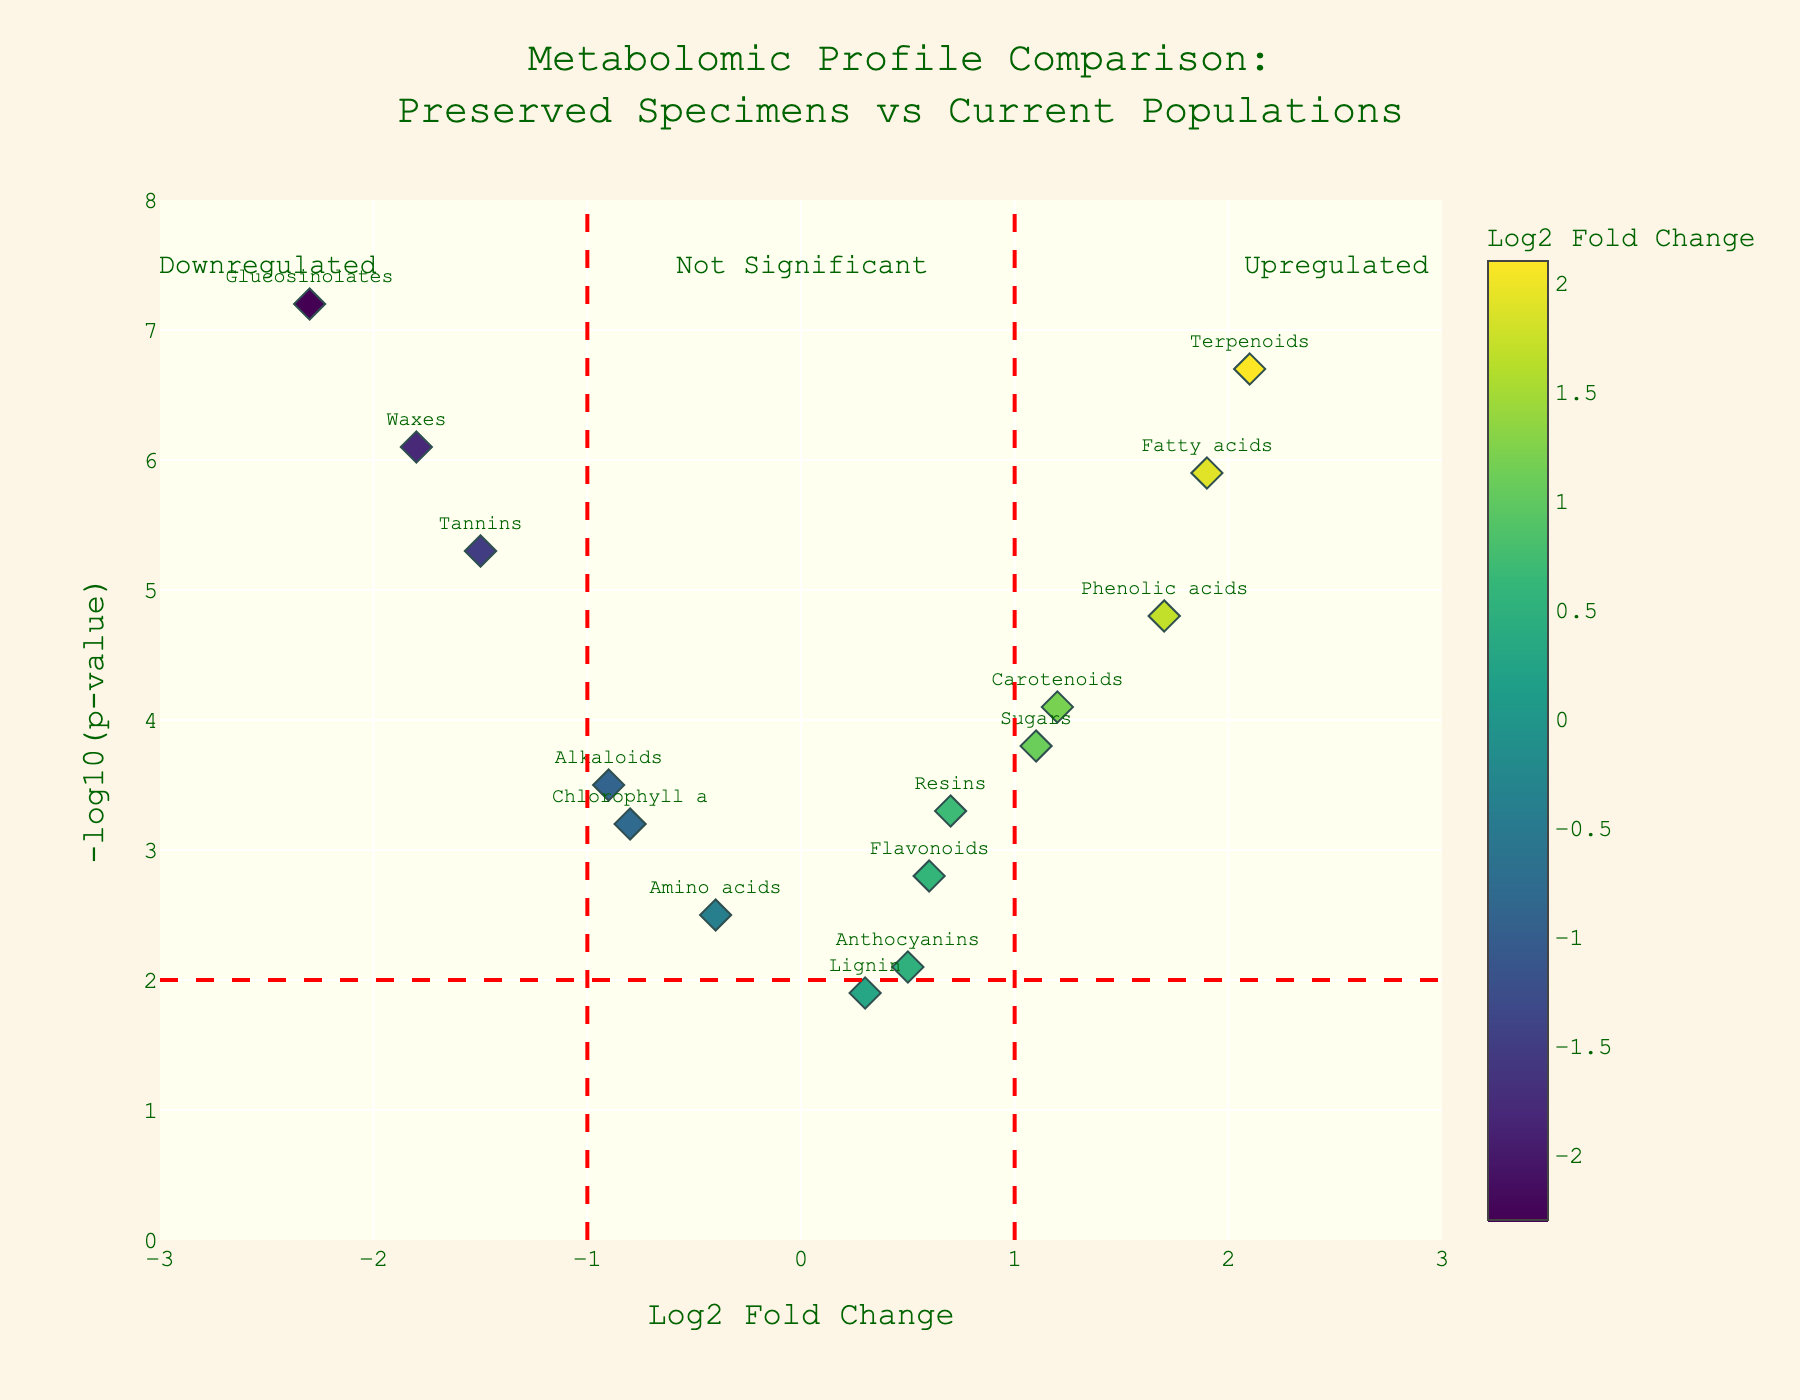What is the title of the figure? The title of a figure is usually found at the top and provides an overview of what the data visualization represents. In this case, it states the purpose of the plot, comparing metabolomic profiles between preserved specimens and current populations.
Answer: Metabolomic Profile Comparison: Preserved Specimens vs Current Populations What is represented on the x-axis and y-axis? The x-axis and y-axis labels describe the data dimensions. The x-axis represents the 'Log2 Fold Change,' indicating the magnitude of change between two conditions. The y-axis represents the '-log10(p-value),' indicating the statistical significance of the change.
Answer: x-axis: Log2 Fold Change, y-axis: -log10(p-value) Which compound has the highest -log10(p-value)? To identify this, look at the y-axis values. The highest plot point on the y-axis denotes the most statistically significant difference. The compound associated with this point is "Glucosinolates."
Answer: Glucosinolates How many compounds have a Log2 Fold Change greater than 1? Count the data points to the right of the vertical line at Log2 Fold Change = 1. The relevant compounds are: Carotenoids, Terpenoids, Fatty acids, Phenolic acids, and Sugars.
Answer: 5 Which compound is the most downregulated? Look for the compound with the lowest Log2 Fold Change value. In this case, "Glucosinolates" has the lowest value at -2.3.
Answer: Glucosinolates Compare the statistical significance between Terpenoids and Tannins. To compare, look at their -log10(p-value) values on the y-axis. Terpenoids have a value of 6.7 while Tannins have a value of 5.3. Thus, Terpenoids are more statistically significant.
Answer: Terpenoids Which compounds are neither upregulated nor downregulated significantly? These compounds are close to Log2 Fold Change of 0 and have a -log10(p-value) less than 2. The relevant compounds are Lignin and Amino acids.
Answer: Lignin, Amino acids How many compounds are highly statistically significant with a -log10(p-value) greater than 6? Count the data points above the horizontal line at -log10(p-value) = 6. The relevant compounds are Terpenoids, Glucosinolates, and Waxes.
Answer: 3 Are there more upregulated or downregulated compounds when Log2 Fold Change thresholds are set at ±1? Count the points to the right of +1 and to the left of -1. There are 5 compounds upregulated (Log2 Fold > 1) and 4 compounds downregulated (Log2 Fold < -1).
Answer: Upregulated Which compound has a Log2 Fold Change closest to 0 but with a high -log10(p-value)? Find the compound closest to the Log2 Fold Change = 0 on the x-axis but with a large y-axis value. "Lignin" is closest to 0 with a -log10(p-value) of 1.9.
Answer: Lignin 